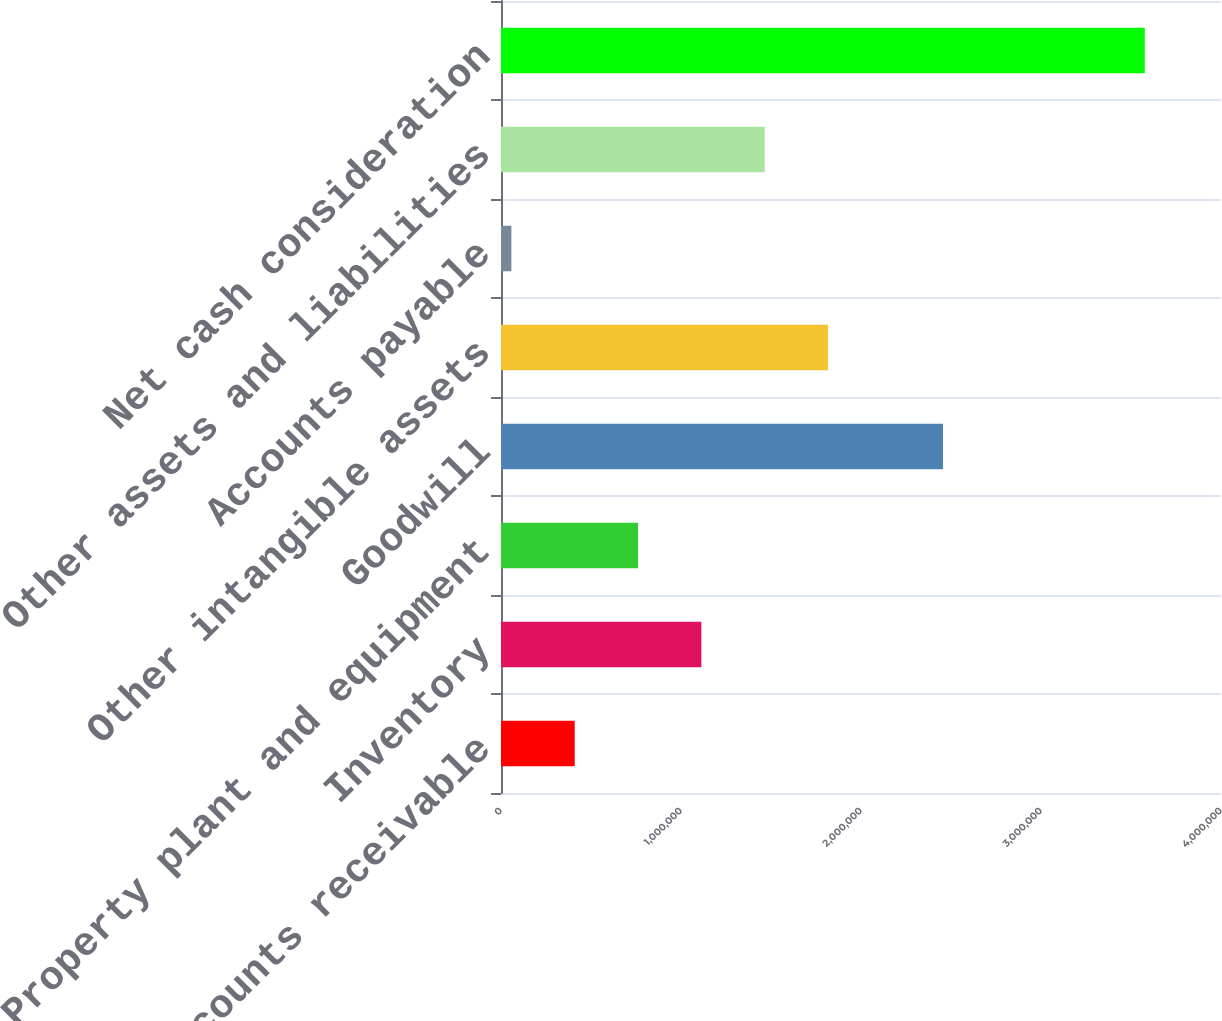<chart> <loc_0><loc_0><loc_500><loc_500><bar_chart><fcel>Accounts receivable<fcel>Inventory<fcel>Property plant and equipment<fcel>Goodwill<fcel>Other intangible assets<fcel>Accounts payable<fcel>Other assets and liabilities<fcel>Net cash consideration<nl><fcel>409512<fcel>1.1133e+06<fcel>761406<fcel>2.45547e+06<fcel>1.81709e+06<fcel>57617<fcel>1.4652e+06<fcel>3.57656e+06<nl></chart> 